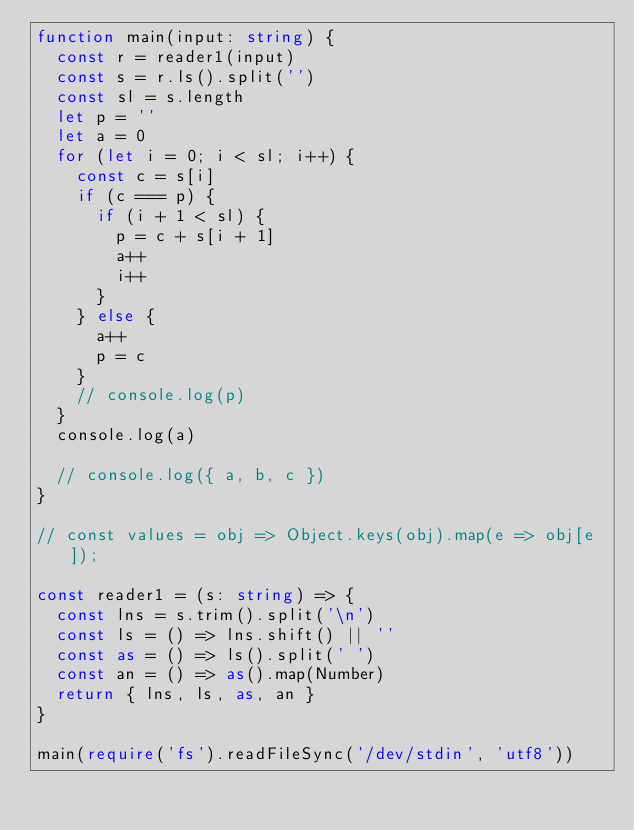Convert code to text. <code><loc_0><loc_0><loc_500><loc_500><_TypeScript_>function main(input: string) {
  const r = reader1(input)
  const s = r.ls().split('')
  const sl = s.length
  let p = ''
  let a = 0
  for (let i = 0; i < sl; i++) {
    const c = s[i]
    if (c === p) {
      if (i + 1 < sl) {
        p = c + s[i + 1]
        a++
        i++
      }
    } else {
      a++
      p = c
    }
    // console.log(p)
  }
  console.log(a)

  // console.log({ a, b, c })
}

// const values = obj => Object.keys(obj).map(e => obj[e]);

const reader1 = (s: string) => {
  const lns = s.trim().split('\n')
  const ls = () => lns.shift() || ''
  const as = () => ls().split(' ')
  const an = () => as().map(Number)
  return { lns, ls, as, an }
}

main(require('fs').readFileSync('/dev/stdin', 'utf8'))
</code> 